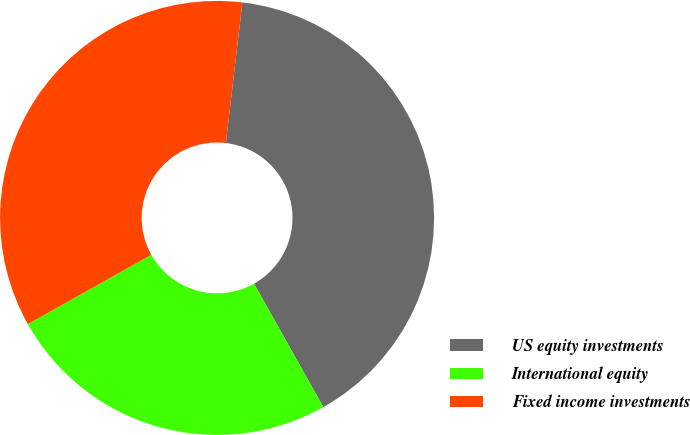Convert chart. <chart><loc_0><loc_0><loc_500><loc_500><pie_chart><fcel>US equity investments<fcel>International equity<fcel>Fixed income investments<nl><fcel>40.0%<fcel>25.0%<fcel>35.0%<nl></chart> 